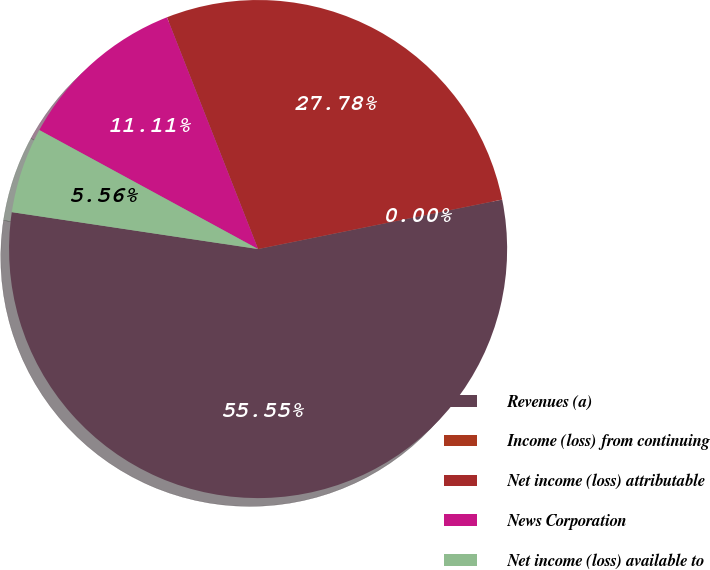<chart> <loc_0><loc_0><loc_500><loc_500><pie_chart><fcel>Revenues (a)<fcel>Income (loss) from continuing<fcel>Net income (loss) attributable<fcel>News Corporation<fcel>Net income (loss) available to<nl><fcel>55.55%<fcel>0.0%<fcel>27.78%<fcel>11.11%<fcel>5.56%<nl></chart> 